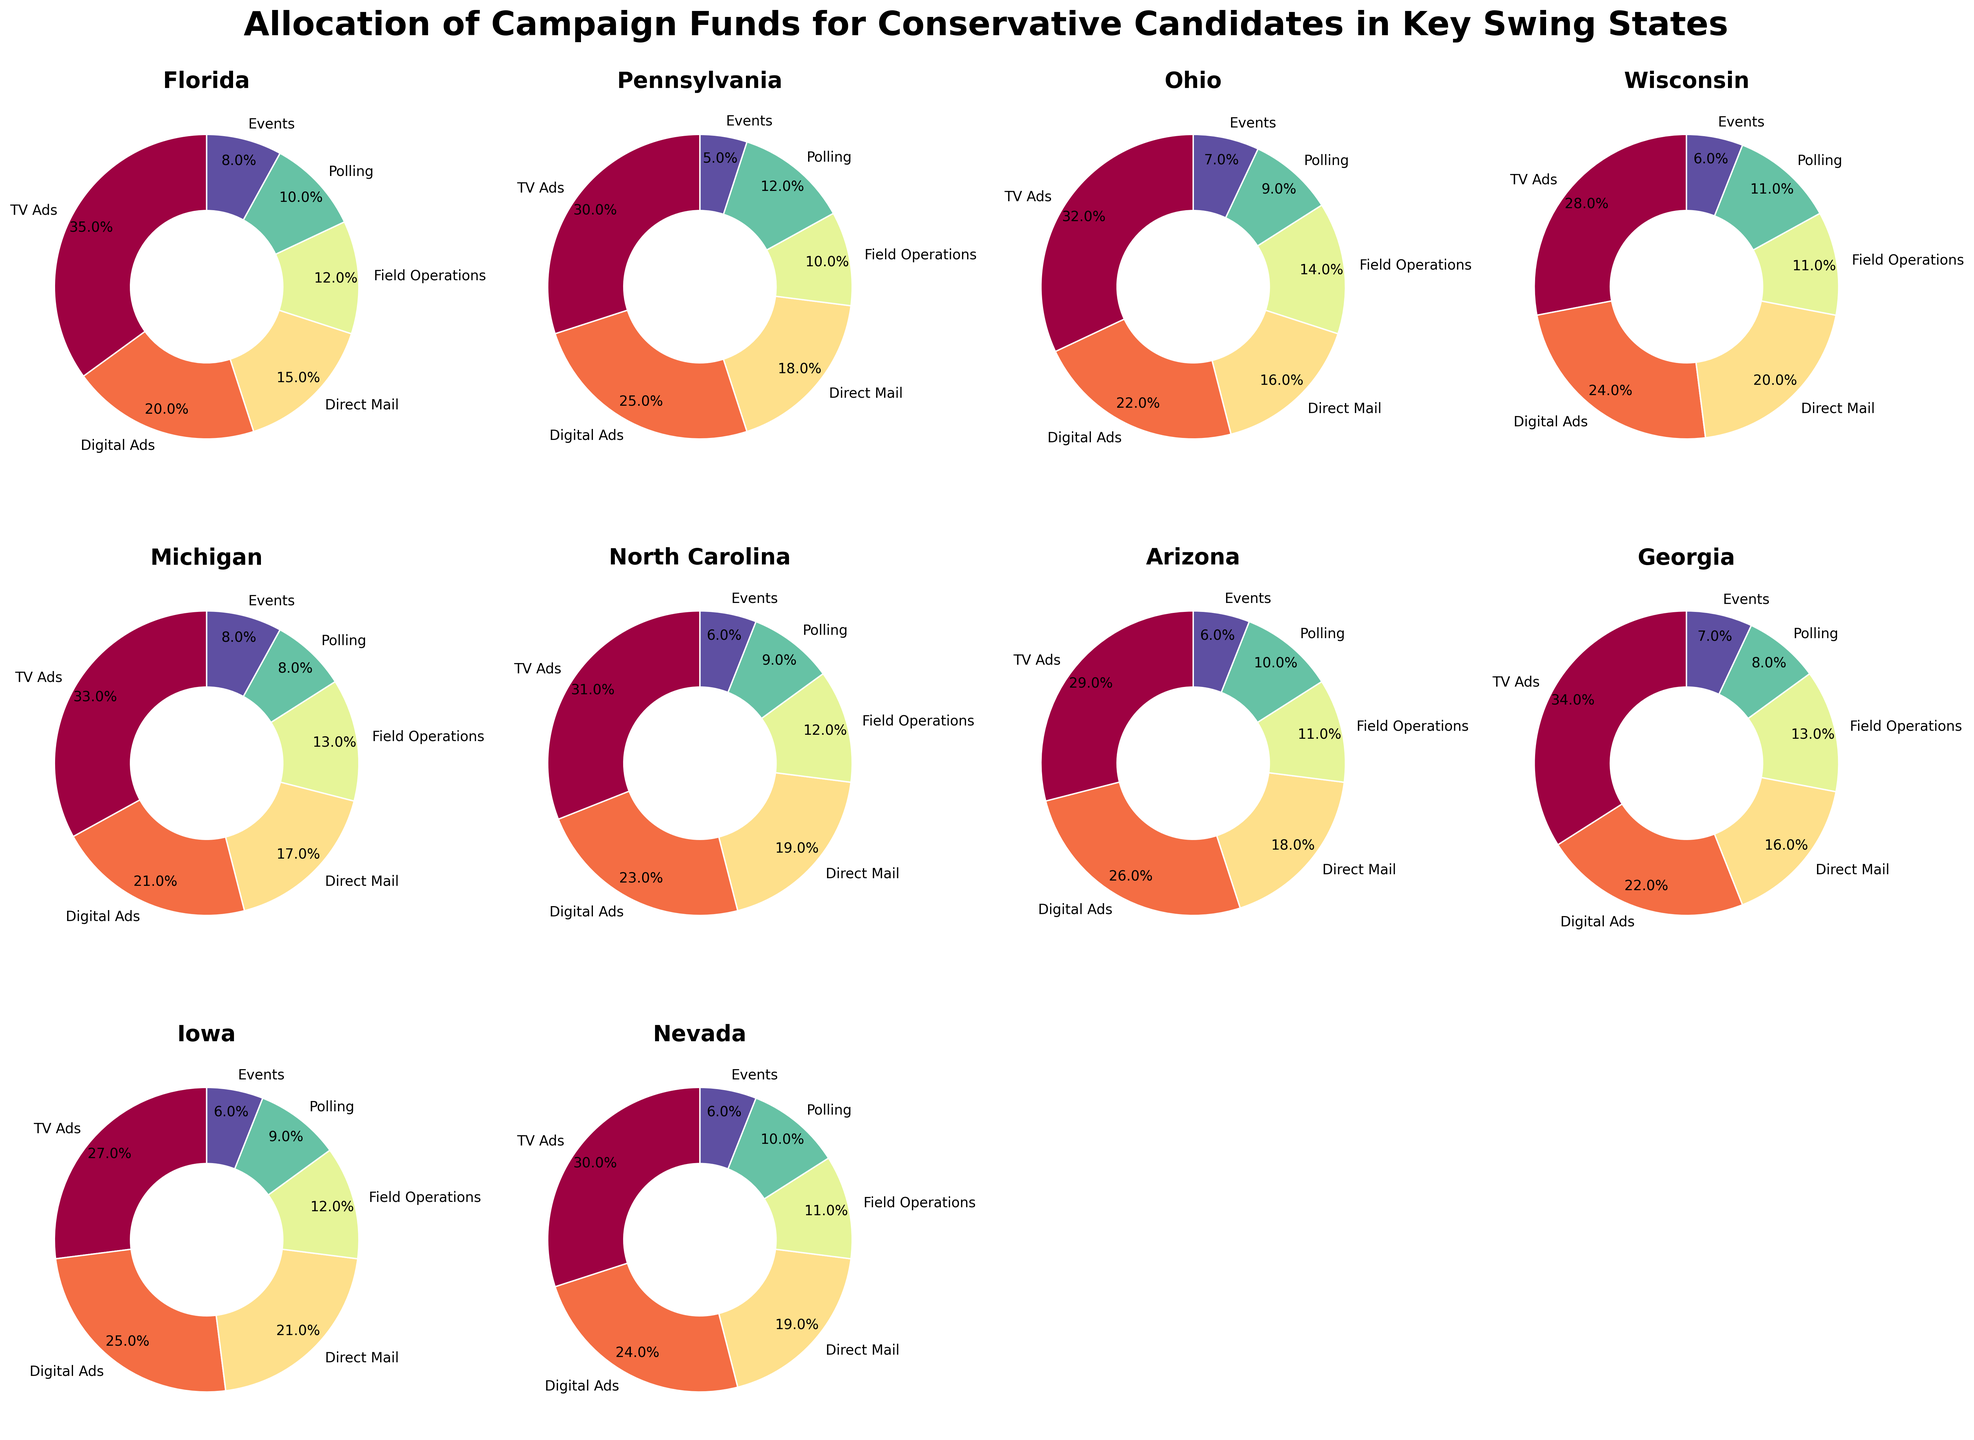Which state allocates the highest percentage to Digital Ads? Digital Ads in different states are represented by different segments in each pie chart. By visually inspecting each pie chart segment labeled "Digital Ads," Pennsylvania allocates the highest percentage (25%) to Digital Ads.
Answer: Pennsylvania Compare the allocation of TV Ads between Florida and Wisconsin. Which state spends more on TV Ads and by what percentage? Identify the "TV Ads" segments in both the Florida and Wisconsin pie charts. Florida allocates 35% to TV Ads, while Wisconsin allocates 28% to TV Ads. The difference is 35% - 28% = 7%. Florida spends 7% more on TV Ads than Wisconsin.
Answer: Florida by 7% What is the total percentage of campaign funds spent on Field Operations and Events in Michigan? In the Michigan pie chart, locate the segments labeled "Field Operations" and "Events." Michigan spends 13% on Field Operations and 8% on Events. The total is 13% + 8% = 21%.
Answer: 21% Which state allocates the smallest percentage to Polling? By reviewing each pie chart segment labeled "Polling," Georgia has the smallest segment allocated to Polling with 8%.
Answer: Georgia What is the difference in the allocation to Direct Mail between Iowa and North Carolina? Observe the "Direct Mail" segments in the Iowa and North Carolina pie charts. Iowa allocates 21% to Direct Mail, while North Carolina allocates 19%. The difference is 21% - 19% = 2%.
Answer: 2% Between Ohio and Nevada, which state allocates a higher percentage to Events, and by how much? Find the "Events" segments in both the Ohio and Nevada pie charts. Ohio allocates 7% to Events, and Nevada allocates 6%. The difference is 7% - 6% = 1%. Ohio allocates 1% more to Events than Nevada.
Answer: Ohio by 1% What is the average percentage allocation to TV Ads across all states? Identify the "TV Ads" percentage values for each state and compute the average. The values are 35, 30, 32, 28, 33, 31, 29, 34, 27, 30. The sum is 309. The average is 309/10 = 30.9%.
Answer: 30.9% Which state spends the most on Field Operations? By inspecting the "Field Operations" segments across all pie charts, Ohio allocates the highest percentage at 14%.
Answer: Ohio Calculate the combined percentage allocation to TV Ads and Digital Ads in Arizona. Locate the "TV Ads" and "Digital Ads" segments in the Arizona pie chart. TV Ads are 29% and Digital Ads are 26%. The combined allocation is 29% + 26% = 55%.
Answer: 55% Between Florida and Georgia, which state has a lower allocation to Direct Mail? Compare the "Direct Mail" segments in the Florida and Georgia pie charts. Florida allocates 15%, and Georgia allocates 16%. Florida allocates a lower percentage to Direct Mail.
Answer: Florida 